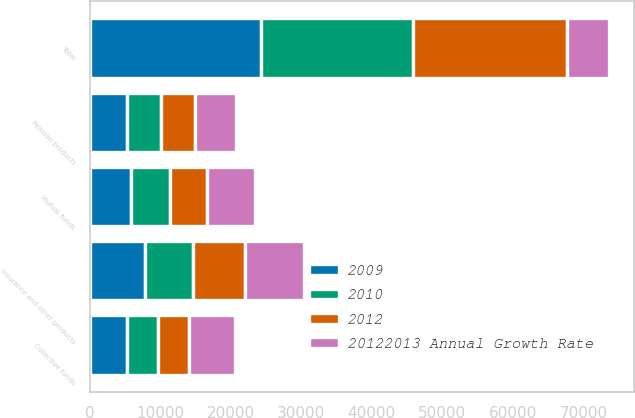Convert chart. <chart><loc_0><loc_0><loc_500><loc_500><stacked_bar_chart><ecel><fcel>Mutual funds<fcel>Collective funds<fcel>Pension products<fcel>Insurance and other products<fcel>Total<nl><fcel>20122013 Annual Growth Rate<fcel>6811<fcel>6428<fcel>5851<fcel>8337<fcel>5852<nl><fcel>2009<fcel>5852<fcel>5363<fcel>5339<fcel>7817<fcel>24371<nl><fcel>2012<fcel>5265<fcel>4437<fcel>4837<fcel>7268<fcel>21807<nl><fcel>2010<fcel>5540<fcel>4350<fcel>4726<fcel>6911<fcel>21527<nl></chart> 